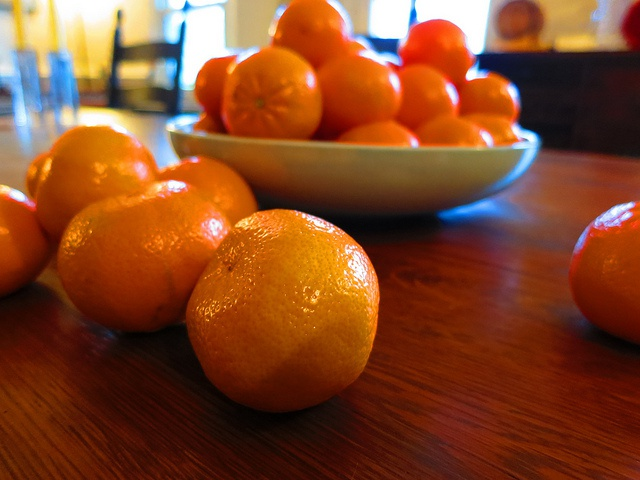Describe the objects in this image and their specific colors. I can see dining table in maroon, tan, black, and red tones, bowl in tan, red, brown, and maroon tones, orange in tan, red, and brown tones, orange in tan, red, maroon, and orange tones, and orange in tan, red, and maroon tones in this image. 